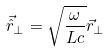<formula> <loc_0><loc_0><loc_500><loc_500>\vec { \hat { r } } _ { \bot } = \sqrt { \frac { \omega } { L c } } \vec { r } _ { \bot }</formula> 